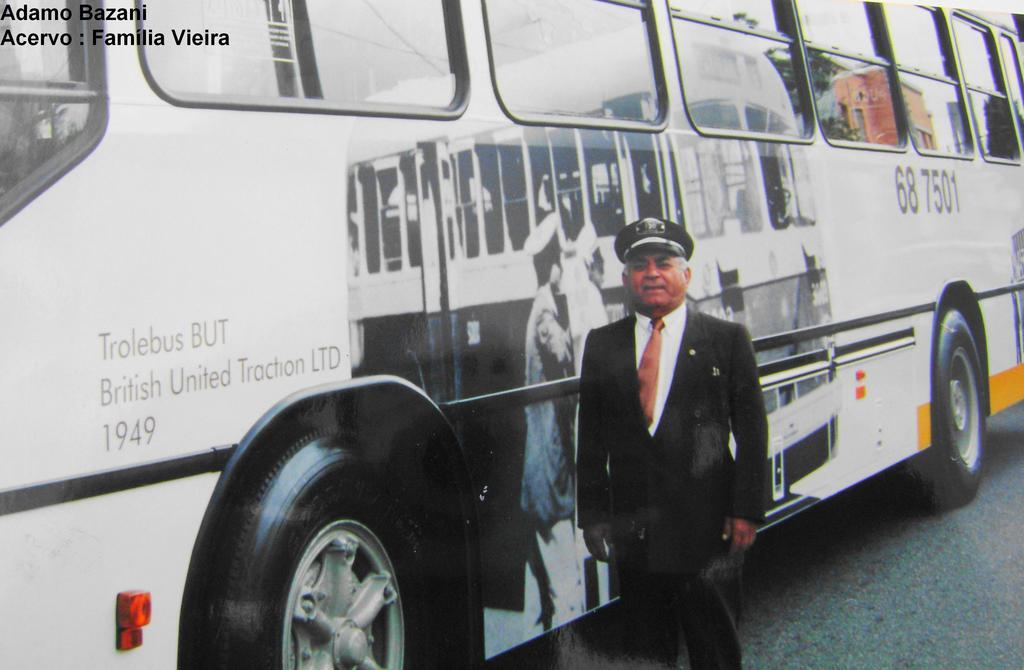<image>
Describe the image concisely. a man in uniform standing along side a british united ltd 1949 bus 